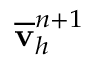Convert formula to latex. <formula><loc_0><loc_0><loc_500><loc_500>\overline { \mathbf v } _ { h } ^ { n + 1 }</formula> 